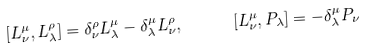<formula> <loc_0><loc_0><loc_500><loc_500>\ [ L _ { \nu } ^ { \mu } , L _ { \lambda } ^ { \rho } ] = \delta _ { \nu } ^ { \rho } L _ { \lambda } ^ { \mu } - \delta _ { \lambda } ^ { \mu } L _ { \nu } ^ { \rho } , \quad \, \ [ L _ { \nu } ^ { \mu } , P _ { \lambda } ] = - \delta _ { \lambda } ^ { \mu } P _ { \nu }</formula> 